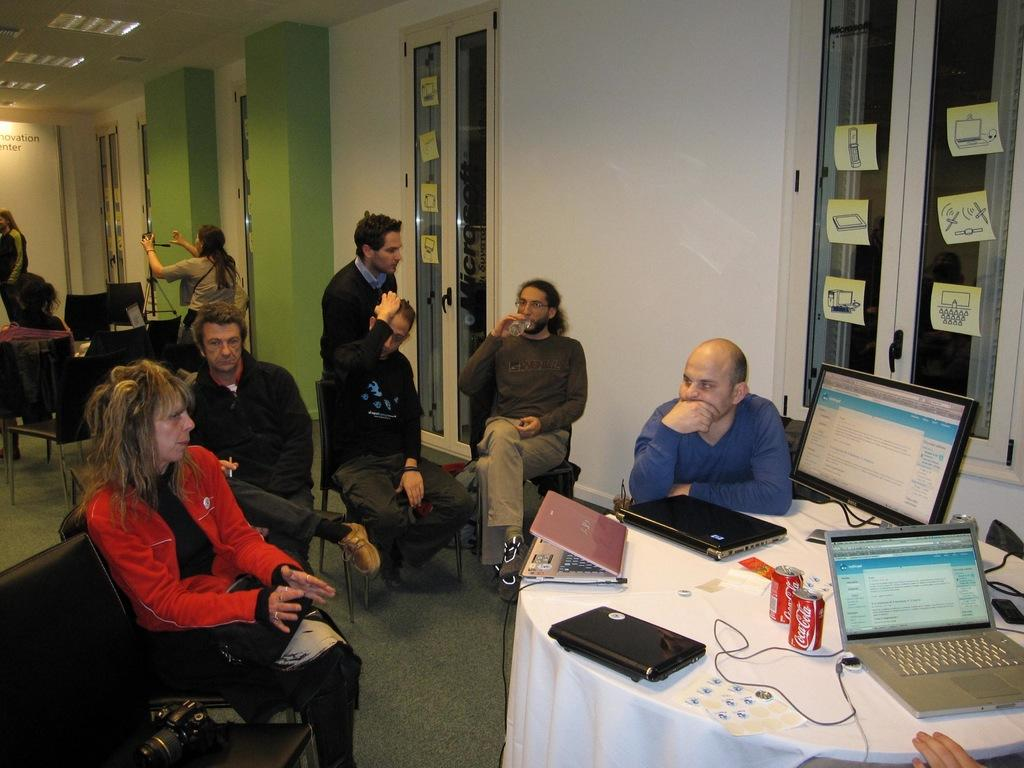What are the people in the image doing? The people in the image are sitting on chairs. What can be seen on the table in the image? There is a laptop and a tin on the table in the image. What type of wine is being served in the image? There is no wine present in the image. What country is depicted in the image? The image does not depict any specific country. 